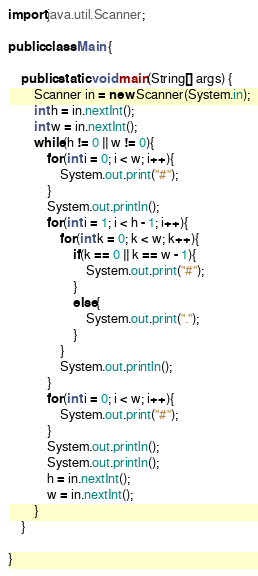<code> <loc_0><loc_0><loc_500><loc_500><_Java_>import java.util.Scanner;

public class Main {

	public static void main(String[] args) {
		Scanner in = new Scanner(System.in);
		int h = in.nextInt();
		int w = in.nextInt();
		while(h != 0 || w != 0){
			for(int i = 0; i < w; i++){
				System.out.print("#");
			}
			System.out.println();
			for(int i = 1; i < h - 1; i++){
				for(int k = 0; k < w; k++){
					if(k == 0 || k == w - 1){
						System.out.print("#");
					}
					else{
						System.out.print(".");
					}
				}
				System.out.println();
			}
			for(int i = 0; i < w; i++){
				System.out.print("#");
			}
			System.out.println();
			System.out.println();
			h = in.nextInt();
			w = in.nextInt();
		}
	}

}</code> 